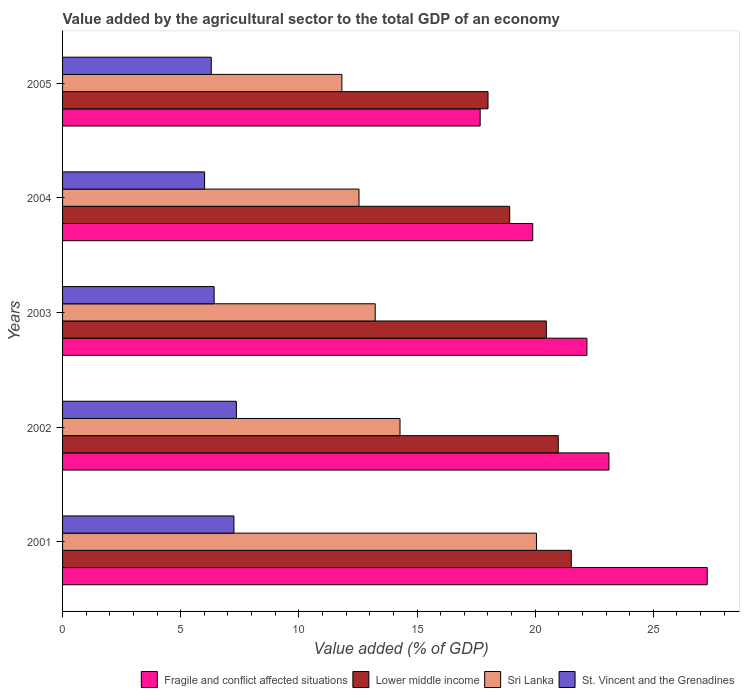How many different coloured bars are there?
Make the answer very short. 4. How many groups of bars are there?
Your answer should be compact. 5. How many bars are there on the 4th tick from the top?
Your answer should be very brief. 4. How many bars are there on the 4th tick from the bottom?
Make the answer very short. 4. What is the label of the 2nd group of bars from the top?
Provide a short and direct response. 2004. In how many cases, is the number of bars for a given year not equal to the number of legend labels?
Your answer should be compact. 0. What is the value added by the agricultural sector to the total GDP in Sri Lanka in 2004?
Give a very brief answer. 12.54. Across all years, what is the maximum value added by the agricultural sector to the total GDP in Lower middle income?
Your answer should be compact. 21.53. Across all years, what is the minimum value added by the agricultural sector to the total GDP in St. Vincent and the Grenadines?
Your response must be concise. 6.01. In which year was the value added by the agricultural sector to the total GDP in St. Vincent and the Grenadines maximum?
Ensure brevity in your answer.  2002. What is the total value added by the agricultural sector to the total GDP in Fragile and conflict affected situations in the graph?
Make the answer very short. 110.16. What is the difference between the value added by the agricultural sector to the total GDP in Lower middle income in 2001 and that in 2004?
Offer a terse response. 2.61. What is the difference between the value added by the agricultural sector to the total GDP in Fragile and conflict affected situations in 2001 and the value added by the agricultural sector to the total GDP in St. Vincent and the Grenadines in 2003?
Ensure brevity in your answer.  20.87. What is the average value added by the agricultural sector to the total GDP in Sri Lanka per year?
Offer a very short reply. 14.39. In the year 2005, what is the difference between the value added by the agricultural sector to the total GDP in Fragile and conflict affected situations and value added by the agricultural sector to the total GDP in Lower middle income?
Make the answer very short. -0.33. What is the ratio of the value added by the agricultural sector to the total GDP in Lower middle income in 2002 to that in 2004?
Provide a succinct answer. 1.11. What is the difference between the highest and the second highest value added by the agricultural sector to the total GDP in St. Vincent and the Grenadines?
Offer a terse response. 0.1. What is the difference between the highest and the lowest value added by the agricultural sector to the total GDP in Lower middle income?
Your response must be concise. 3.52. In how many years, is the value added by the agricultural sector to the total GDP in St. Vincent and the Grenadines greater than the average value added by the agricultural sector to the total GDP in St. Vincent and the Grenadines taken over all years?
Give a very brief answer. 2. Is the sum of the value added by the agricultural sector to the total GDP in Sri Lanka in 2002 and 2005 greater than the maximum value added by the agricultural sector to the total GDP in St. Vincent and the Grenadines across all years?
Provide a succinct answer. Yes. Is it the case that in every year, the sum of the value added by the agricultural sector to the total GDP in St. Vincent and the Grenadines and value added by the agricultural sector to the total GDP in Sri Lanka is greater than the sum of value added by the agricultural sector to the total GDP in Fragile and conflict affected situations and value added by the agricultural sector to the total GDP in Lower middle income?
Provide a short and direct response. No. What does the 4th bar from the top in 2005 represents?
Make the answer very short. Fragile and conflict affected situations. What does the 3rd bar from the bottom in 2005 represents?
Make the answer very short. Sri Lanka. Are all the bars in the graph horizontal?
Your answer should be very brief. Yes. How many years are there in the graph?
Keep it short and to the point. 5. What is the difference between two consecutive major ticks on the X-axis?
Keep it short and to the point. 5. Are the values on the major ticks of X-axis written in scientific E-notation?
Keep it short and to the point. No. Does the graph contain any zero values?
Your response must be concise. No. Where does the legend appear in the graph?
Offer a terse response. Bottom right. How many legend labels are there?
Offer a terse response. 4. What is the title of the graph?
Keep it short and to the point. Value added by the agricultural sector to the total GDP of an economy. Does "Swaziland" appear as one of the legend labels in the graph?
Your answer should be compact. No. What is the label or title of the X-axis?
Provide a short and direct response. Value added (% of GDP). What is the label or title of the Y-axis?
Your answer should be very brief. Years. What is the Value added (% of GDP) of Fragile and conflict affected situations in 2001?
Your response must be concise. 27.28. What is the Value added (% of GDP) in Lower middle income in 2001?
Ensure brevity in your answer.  21.53. What is the Value added (% of GDP) in Sri Lanka in 2001?
Your response must be concise. 20.05. What is the Value added (% of GDP) of St. Vincent and the Grenadines in 2001?
Make the answer very short. 7.25. What is the Value added (% of GDP) in Fragile and conflict affected situations in 2002?
Keep it short and to the point. 23.12. What is the Value added (% of GDP) in Lower middle income in 2002?
Provide a short and direct response. 20.98. What is the Value added (% of GDP) in Sri Lanka in 2002?
Keep it short and to the point. 14.28. What is the Value added (% of GDP) of St. Vincent and the Grenadines in 2002?
Keep it short and to the point. 7.36. What is the Value added (% of GDP) in Fragile and conflict affected situations in 2003?
Offer a terse response. 22.19. What is the Value added (% of GDP) of Lower middle income in 2003?
Ensure brevity in your answer.  20.47. What is the Value added (% of GDP) in Sri Lanka in 2003?
Keep it short and to the point. 13.23. What is the Value added (% of GDP) in St. Vincent and the Grenadines in 2003?
Provide a succinct answer. 6.41. What is the Value added (% of GDP) of Fragile and conflict affected situations in 2004?
Provide a succinct answer. 19.9. What is the Value added (% of GDP) in Lower middle income in 2004?
Provide a short and direct response. 18.92. What is the Value added (% of GDP) in Sri Lanka in 2004?
Your answer should be very brief. 12.54. What is the Value added (% of GDP) of St. Vincent and the Grenadines in 2004?
Offer a terse response. 6.01. What is the Value added (% of GDP) in Fragile and conflict affected situations in 2005?
Your answer should be very brief. 17.67. What is the Value added (% of GDP) of Lower middle income in 2005?
Your answer should be compact. 18. What is the Value added (% of GDP) in Sri Lanka in 2005?
Make the answer very short. 11.82. What is the Value added (% of GDP) in St. Vincent and the Grenadines in 2005?
Your answer should be compact. 6.29. Across all years, what is the maximum Value added (% of GDP) in Fragile and conflict affected situations?
Your answer should be compact. 27.28. Across all years, what is the maximum Value added (% of GDP) in Lower middle income?
Ensure brevity in your answer.  21.53. Across all years, what is the maximum Value added (% of GDP) of Sri Lanka?
Keep it short and to the point. 20.05. Across all years, what is the maximum Value added (% of GDP) of St. Vincent and the Grenadines?
Give a very brief answer. 7.36. Across all years, what is the minimum Value added (% of GDP) of Fragile and conflict affected situations?
Offer a terse response. 17.67. Across all years, what is the minimum Value added (% of GDP) of Lower middle income?
Your answer should be very brief. 18. Across all years, what is the minimum Value added (% of GDP) of Sri Lanka?
Your answer should be compact. 11.82. Across all years, what is the minimum Value added (% of GDP) in St. Vincent and the Grenadines?
Provide a succinct answer. 6.01. What is the total Value added (% of GDP) of Fragile and conflict affected situations in the graph?
Your answer should be very brief. 110.16. What is the total Value added (% of GDP) in Lower middle income in the graph?
Your response must be concise. 99.9. What is the total Value added (% of GDP) in Sri Lanka in the graph?
Ensure brevity in your answer.  71.93. What is the total Value added (% of GDP) of St. Vincent and the Grenadines in the graph?
Provide a short and direct response. 33.32. What is the difference between the Value added (% of GDP) in Fragile and conflict affected situations in 2001 and that in 2002?
Give a very brief answer. 4.16. What is the difference between the Value added (% of GDP) in Lower middle income in 2001 and that in 2002?
Your answer should be compact. 0.55. What is the difference between the Value added (% of GDP) of Sri Lanka in 2001 and that in 2002?
Provide a succinct answer. 5.77. What is the difference between the Value added (% of GDP) in St. Vincent and the Grenadines in 2001 and that in 2002?
Your answer should be very brief. -0.1. What is the difference between the Value added (% of GDP) in Fragile and conflict affected situations in 2001 and that in 2003?
Your answer should be compact. 5.09. What is the difference between the Value added (% of GDP) of Lower middle income in 2001 and that in 2003?
Make the answer very short. 1.05. What is the difference between the Value added (% of GDP) of Sri Lanka in 2001 and that in 2003?
Make the answer very short. 6.82. What is the difference between the Value added (% of GDP) in St. Vincent and the Grenadines in 2001 and that in 2003?
Give a very brief answer. 0.84. What is the difference between the Value added (% of GDP) of Fragile and conflict affected situations in 2001 and that in 2004?
Your response must be concise. 7.38. What is the difference between the Value added (% of GDP) of Lower middle income in 2001 and that in 2004?
Provide a succinct answer. 2.61. What is the difference between the Value added (% of GDP) in Sri Lanka in 2001 and that in 2004?
Provide a succinct answer. 7.51. What is the difference between the Value added (% of GDP) in St. Vincent and the Grenadines in 2001 and that in 2004?
Offer a terse response. 1.24. What is the difference between the Value added (% of GDP) of Fragile and conflict affected situations in 2001 and that in 2005?
Provide a succinct answer. 9.61. What is the difference between the Value added (% of GDP) of Lower middle income in 2001 and that in 2005?
Give a very brief answer. 3.52. What is the difference between the Value added (% of GDP) in Sri Lanka in 2001 and that in 2005?
Provide a succinct answer. 8.23. What is the difference between the Value added (% of GDP) of St. Vincent and the Grenadines in 2001 and that in 2005?
Offer a very short reply. 0.96. What is the difference between the Value added (% of GDP) in Fragile and conflict affected situations in 2002 and that in 2003?
Offer a terse response. 0.93. What is the difference between the Value added (% of GDP) in Lower middle income in 2002 and that in 2003?
Ensure brevity in your answer.  0.5. What is the difference between the Value added (% of GDP) of Sri Lanka in 2002 and that in 2003?
Keep it short and to the point. 1.05. What is the difference between the Value added (% of GDP) in St. Vincent and the Grenadines in 2002 and that in 2003?
Your response must be concise. 0.94. What is the difference between the Value added (% of GDP) of Fragile and conflict affected situations in 2002 and that in 2004?
Offer a terse response. 3.23. What is the difference between the Value added (% of GDP) in Lower middle income in 2002 and that in 2004?
Your answer should be compact. 2.05. What is the difference between the Value added (% of GDP) in Sri Lanka in 2002 and that in 2004?
Make the answer very short. 1.74. What is the difference between the Value added (% of GDP) in St. Vincent and the Grenadines in 2002 and that in 2004?
Provide a short and direct response. 1.35. What is the difference between the Value added (% of GDP) of Fragile and conflict affected situations in 2002 and that in 2005?
Provide a succinct answer. 5.45. What is the difference between the Value added (% of GDP) in Lower middle income in 2002 and that in 2005?
Offer a terse response. 2.97. What is the difference between the Value added (% of GDP) in Sri Lanka in 2002 and that in 2005?
Offer a terse response. 2.46. What is the difference between the Value added (% of GDP) in St. Vincent and the Grenadines in 2002 and that in 2005?
Offer a terse response. 1.06. What is the difference between the Value added (% of GDP) of Fragile and conflict affected situations in 2003 and that in 2004?
Give a very brief answer. 2.29. What is the difference between the Value added (% of GDP) of Lower middle income in 2003 and that in 2004?
Your answer should be compact. 1.55. What is the difference between the Value added (% of GDP) in Sri Lanka in 2003 and that in 2004?
Your response must be concise. 0.69. What is the difference between the Value added (% of GDP) of St. Vincent and the Grenadines in 2003 and that in 2004?
Make the answer very short. 0.4. What is the difference between the Value added (% of GDP) of Fragile and conflict affected situations in 2003 and that in 2005?
Offer a terse response. 4.52. What is the difference between the Value added (% of GDP) of Lower middle income in 2003 and that in 2005?
Your answer should be compact. 2.47. What is the difference between the Value added (% of GDP) in Sri Lanka in 2003 and that in 2005?
Keep it short and to the point. 1.41. What is the difference between the Value added (% of GDP) in St. Vincent and the Grenadines in 2003 and that in 2005?
Make the answer very short. 0.12. What is the difference between the Value added (% of GDP) of Fragile and conflict affected situations in 2004 and that in 2005?
Keep it short and to the point. 2.22. What is the difference between the Value added (% of GDP) of Lower middle income in 2004 and that in 2005?
Give a very brief answer. 0.92. What is the difference between the Value added (% of GDP) of Sri Lanka in 2004 and that in 2005?
Your response must be concise. 0.72. What is the difference between the Value added (% of GDP) of St. Vincent and the Grenadines in 2004 and that in 2005?
Offer a very short reply. -0.28. What is the difference between the Value added (% of GDP) of Fragile and conflict affected situations in 2001 and the Value added (% of GDP) of Lower middle income in 2002?
Keep it short and to the point. 6.31. What is the difference between the Value added (% of GDP) in Fragile and conflict affected situations in 2001 and the Value added (% of GDP) in Sri Lanka in 2002?
Your response must be concise. 13. What is the difference between the Value added (% of GDP) of Fragile and conflict affected situations in 2001 and the Value added (% of GDP) of St. Vincent and the Grenadines in 2002?
Make the answer very short. 19.92. What is the difference between the Value added (% of GDP) in Lower middle income in 2001 and the Value added (% of GDP) in Sri Lanka in 2002?
Provide a succinct answer. 7.25. What is the difference between the Value added (% of GDP) of Lower middle income in 2001 and the Value added (% of GDP) of St. Vincent and the Grenadines in 2002?
Offer a terse response. 14.17. What is the difference between the Value added (% of GDP) of Sri Lanka in 2001 and the Value added (% of GDP) of St. Vincent and the Grenadines in 2002?
Give a very brief answer. 12.7. What is the difference between the Value added (% of GDP) of Fragile and conflict affected situations in 2001 and the Value added (% of GDP) of Lower middle income in 2003?
Ensure brevity in your answer.  6.81. What is the difference between the Value added (% of GDP) in Fragile and conflict affected situations in 2001 and the Value added (% of GDP) in Sri Lanka in 2003?
Keep it short and to the point. 14.05. What is the difference between the Value added (% of GDP) of Fragile and conflict affected situations in 2001 and the Value added (% of GDP) of St. Vincent and the Grenadines in 2003?
Your answer should be compact. 20.87. What is the difference between the Value added (% of GDP) of Lower middle income in 2001 and the Value added (% of GDP) of Sri Lanka in 2003?
Keep it short and to the point. 8.3. What is the difference between the Value added (% of GDP) of Lower middle income in 2001 and the Value added (% of GDP) of St. Vincent and the Grenadines in 2003?
Offer a very short reply. 15.11. What is the difference between the Value added (% of GDP) of Sri Lanka in 2001 and the Value added (% of GDP) of St. Vincent and the Grenadines in 2003?
Give a very brief answer. 13.64. What is the difference between the Value added (% of GDP) in Fragile and conflict affected situations in 2001 and the Value added (% of GDP) in Lower middle income in 2004?
Your answer should be very brief. 8.36. What is the difference between the Value added (% of GDP) in Fragile and conflict affected situations in 2001 and the Value added (% of GDP) in Sri Lanka in 2004?
Your answer should be compact. 14.74. What is the difference between the Value added (% of GDP) in Fragile and conflict affected situations in 2001 and the Value added (% of GDP) in St. Vincent and the Grenadines in 2004?
Offer a very short reply. 21.27. What is the difference between the Value added (% of GDP) in Lower middle income in 2001 and the Value added (% of GDP) in Sri Lanka in 2004?
Keep it short and to the point. 8.98. What is the difference between the Value added (% of GDP) of Lower middle income in 2001 and the Value added (% of GDP) of St. Vincent and the Grenadines in 2004?
Give a very brief answer. 15.52. What is the difference between the Value added (% of GDP) in Sri Lanka in 2001 and the Value added (% of GDP) in St. Vincent and the Grenadines in 2004?
Provide a short and direct response. 14.04. What is the difference between the Value added (% of GDP) of Fragile and conflict affected situations in 2001 and the Value added (% of GDP) of Lower middle income in 2005?
Make the answer very short. 9.28. What is the difference between the Value added (% of GDP) of Fragile and conflict affected situations in 2001 and the Value added (% of GDP) of Sri Lanka in 2005?
Your answer should be compact. 15.46. What is the difference between the Value added (% of GDP) in Fragile and conflict affected situations in 2001 and the Value added (% of GDP) in St. Vincent and the Grenadines in 2005?
Your answer should be very brief. 20.99. What is the difference between the Value added (% of GDP) of Lower middle income in 2001 and the Value added (% of GDP) of Sri Lanka in 2005?
Give a very brief answer. 9.71. What is the difference between the Value added (% of GDP) in Lower middle income in 2001 and the Value added (% of GDP) in St. Vincent and the Grenadines in 2005?
Provide a short and direct response. 15.24. What is the difference between the Value added (% of GDP) of Sri Lanka in 2001 and the Value added (% of GDP) of St. Vincent and the Grenadines in 2005?
Your answer should be compact. 13.76. What is the difference between the Value added (% of GDP) in Fragile and conflict affected situations in 2002 and the Value added (% of GDP) in Lower middle income in 2003?
Give a very brief answer. 2.65. What is the difference between the Value added (% of GDP) in Fragile and conflict affected situations in 2002 and the Value added (% of GDP) in Sri Lanka in 2003?
Ensure brevity in your answer.  9.89. What is the difference between the Value added (% of GDP) in Fragile and conflict affected situations in 2002 and the Value added (% of GDP) in St. Vincent and the Grenadines in 2003?
Ensure brevity in your answer.  16.71. What is the difference between the Value added (% of GDP) of Lower middle income in 2002 and the Value added (% of GDP) of Sri Lanka in 2003?
Your response must be concise. 7.74. What is the difference between the Value added (% of GDP) of Lower middle income in 2002 and the Value added (% of GDP) of St. Vincent and the Grenadines in 2003?
Make the answer very short. 14.56. What is the difference between the Value added (% of GDP) of Sri Lanka in 2002 and the Value added (% of GDP) of St. Vincent and the Grenadines in 2003?
Give a very brief answer. 7.87. What is the difference between the Value added (% of GDP) in Fragile and conflict affected situations in 2002 and the Value added (% of GDP) in Lower middle income in 2004?
Your response must be concise. 4.2. What is the difference between the Value added (% of GDP) of Fragile and conflict affected situations in 2002 and the Value added (% of GDP) of Sri Lanka in 2004?
Ensure brevity in your answer.  10.58. What is the difference between the Value added (% of GDP) in Fragile and conflict affected situations in 2002 and the Value added (% of GDP) in St. Vincent and the Grenadines in 2004?
Your answer should be very brief. 17.11. What is the difference between the Value added (% of GDP) of Lower middle income in 2002 and the Value added (% of GDP) of Sri Lanka in 2004?
Ensure brevity in your answer.  8.43. What is the difference between the Value added (% of GDP) in Lower middle income in 2002 and the Value added (% of GDP) in St. Vincent and the Grenadines in 2004?
Provide a short and direct response. 14.97. What is the difference between the Value added (% of GDP) in Sri Lanka in 2002 and the Value added (% of GDP) in St. Vincent and the Grenadines in 2004?
Ensure brevity in your answer.  8.27. What is the difference between the Value added (% of GDP) in Fragile and conflict affected situations in 2002 and the Value added (% of GDP) in Lower middle income in 2005?
Keep it short and to the point. 5.12. What is the difference between the Value added (% of GDP) in Fragile and conflict affected situations in 2002 and the Value added (% of GDP) in Sri Lanka in 2005?
Provide a short and direct response. 11.3. What is the difference between the Value added (% of GDP) in Fragile and conflict affected situations in 2002 and the Value added (% of GDP) in St. Vincent and the Grenadines in 2005?
Your answer should be very brief. 16.83. What is the difference between the Value added (% of GDP) in Lower middle income in 2002 and the Value added (% of GDP) in Sri Lanka in 2005?
Your answer should be very brief. 9.16. What is the difference between the Value added (% of GDP) in Lower middle income in 2002 and the Value added (% of GDP) in St. Vincent and the Grenadines in 2005?
Give a very brief answer. 14.68. What is the difference between the Value added (% of GDP) of Sri Lanka in 2002 and the Value added (% of GDP) of St. Vincent and the Grenadines in 2005?
Your answer should be very brief. 7.99. What is the difference between the Value added (% of GDP) of Fragile and conflict affected situations in 2003 and the Value added (% of GDP) of Lower middle income in 2004?
Ensure brevity in your answer.  3.27. What is the difference between the Value added (% of GDP) in Fragile and conflict affected situations in 2003 and the Value added (% of GDP) in Sri Lanka in 2004?
Provide a succinct answer. 9.64. What is the difference between the Value added (% of GDP) of Fragile and conflict affected situations in 2003 and the Value added (% of GDP) of St. Vincent and the Grenadines in 2004?
Give a very brief answer. 16.18. What is the difference between the Value added (% of GDP) of Lower middle income in 2003 and the Value added (% of GDP) of Sri Lanka in 2004?
Ensure brevity in your answer.  7.93. What is the difference between the Value added (% of GDP) of Lower middle income in 2003 and the Value added (% of GDP) of St. Vincent and the Grenadines in 2004?
Provide a succinct answer. 14.46. What is the difference between the Value added (% of GDP) of Sri Lanka in 2003 and the Value added (% of GDP) of St. Vincent and the Grenadines in 2004?
Ensure brevity in your answer.  7.22. What is the difference between the Value added (% of GDP) of Fragile and conflict affected situations in 2003 and the Value added (% of GDP) of Lower middle income in 2005?
Your answer should be compact. 4.18. What is the difference between the Value added (% of GDP) in Fragile and conflict affected situations in 2003 and the Value added (% of GDP) in Sri Lanka in 2005?
Provide a short and direct response. 10.37. What is the difference between the Value added (% of GDP) in Fragile and conflict affected situations in 2003 and the Value added (% of GDP) in St. Vincent and the Grenadines in 2005?
Offer a terse response. 15.9. What is the difference between the Value added (% of GDP) of Lower middle income in 2003 and the Value added (% of GDP) of Sri Lanka in 2005?
Your response must be concise. 8.65. What is the difference between the Value added (% of GDP) in Lower middle income in 2003 and the Value added (% of GDP) in St. Vincent and the Grenadines in 2005?
Make the answer very short. 14.18. What is the difference between the Value added (% of GDP) of Sri Lanka in 2003 and the Value added (% of GDP) of St. Vincent and the Grenadines in 2005?
Offer a terse response. 6.94. What is the difference between the Value added (% of GDP) in Fragile and conflict affected situations in 2004 and the Value added (% of GDP) in Lower middle income in 2005?
Provide a succinct answer. 1.89. What is the difference between the Value added (% of GDP) of Fragile and conflict affected situations in 2004 and the Value added (% of GDP) of Sri Lanka in 2005?
Your answer should be compact. 8.08. What is the difference between the Value added (% of GDP) in Fragile and conflict affected situations in 2004 and the Value added (% of GDP) in St. Vincent and the Grenadines in 2005?
Provide a short and direct response. 13.6. What is the difference between the Value added (% of GDP) in Lower middle income in 2004 and the Value added (% of GDP) in Sri Lanka in 2005?
Provide a succinct answer. 7.1. What is the difference between the Value added (% of GDP) in Lower middle income in 2004 and the Value added (% of GDP) in St. Vincent and the Grenadines in 2005?
Your answer should be very brief. 12.63. What is the difference between the Value added (% of GDP) in Sri Lanka in 2004 and the Value added (% of GDP) in St. Vincent and the Grenadines in 2005?
Ensure brevity in your answer.  6.25. What is the average Value added (% of GDP) of Fragile and conflict affected situations per year?
Your answer should be very brief. 22.03. What is the average Value added (% of GDP) of Lower middle income per year?
Ensure brevity in your answer.  19.98. What is the average Value added (% of GDP) in Sri Lanka per year?
Provide a short and direct response. 14.39. What is the average Value added (% of GDP) in St. Vincent and the Grenadines per year?
Provide a succinct answer. 6.66. In the year 2001, what is the difference between the Value added (% of GDP) in Fragile and conflict affected situations and Value added (% of GDP) in Lower middle income?
Offer a very short reply. 5.75. In the year 2001, what is the difference between the Value added (% of GDP) in Fragile and conflict affected situations and Value added (% of GDP) in Sri Lanka?
Offer a terse response. 7.23. In the year 2001, what is the difference between the Value added (% of GDP) in Fragile and conflict affected situations and Value added (% of GDP) in St. Vincent and the Grenadines?
Offer a very short reply. 20.03. In the year 2001, what is the difference between the Value added (% of GDP) of Lower middle income and Value added (% of GDP) of Sri Lanka?
Give a very brief answer. 1.47. In the year 2001, what is the difference between the Value added (% of GDP) of Lower middle income and Value added (% of GDP) of St. Vincent and the Grenadines?
Give a very brief answer. 14.28. In the year 2001, what is the difference between the Value added (% of GDP) of Sri Lanka and Value added (% of GDP) of St. Vincent and the Grenadines?
Keep it short and to the point. 12.8. In the year 2002, what is the difference between the Value added (% of GDP) of Fragile and conflict affected situations and Value added (% of GDP) of Lower middle income?
Provide a short and direct response. 2.15. In the year 2002, what is the difference between the Value added (% of GDP) of Fragile and conflict affected situations and Value added (% of GDP) of Sri Lanka?
Provide a short and direct response. 8.84. In the year 2002, what is the difference between the Value added (% of GDP) in Fragile and conflict affected situations and Value added (% of GDP) in St. Vincent and the Grenadines?
Keep it short and to the point. 15.76. In the year 2002, what is the difference between the Value added (% of GDP) of Lower middle income and Value added (% of GDP) of Sri Lanka?
Provide a succinct answer. 6.7. In the year 2002, what is the difference between the Value added (% of GDP) of Lower middle income and Value added (% of GDP) of St. Vincent and the Grenadines?
Your answer should be very brief. 13.62. In the year 2002, what is the difference between the Value added (% of GDP) in Sri Lanka and Value added (% of GDP) in St. Vincent and the Grenadines?
Your answer should be very brief. 6.92. In the year 2003, what is the difference between the Value added (% of GDP) of Fragile and conflict affected situations and Value added (% of GDP) of Lower middle income?
Make the answer very short. 1.71. In the year 2003, what is the difference between the Value added (% of GDP) in Fragile and conflict affected situations and Value added (% of GDP) in Sri Lanka?
Make the answer very short. 8.96. In the year 2003, what is the difference between the Value added (% of GDP) in Fragile and conflict affected situations and Value added (% of GDP) in St. Vincent and the Grenadines?
Ensure brevity in your answer.  15.77. In the year 2003, what is the difference between the Value added (% of GDP) in Lower middle income and Value added (% of GDP) in Sri Lanka?
Your answer should be compact. 7.24. In the year 2003, what is the difference between the Value added (% of GDP) in Lower middle income and Value added (% of GDP) in St. Vincent and the Grenadines?
Offer a terse response. 14.06. In the year 2003, what is the difference between the Value added (% of GDP) of Sri Lanka and Value added (% of GDP) of St. Vincent and the Grenadines?
Make the answer very short. 6.82. In the year 2004, what is the difference between the Value added (% of GDP) of Fragile and conflict affected situations and Value added (% of GDP) of Lower middle income?
Provide a succinct answer. 0.97. In the year 2004, what is the difference between the Value added (% of GDP) in Fragile and conflict affected situations and Value added (% of GDP) in Sri Lanka?
Keep it short and to the point. 7.35. In the year 2004, what is the difference between the Value added (% of GDP) in Fragile and conflict affected situations and Value added (% of GDP) in St. Vincent and the Grenadines?
Ensure brevity in your answer.  13.89. In the year 2004, what is the difference between the Value added (% of GDP) of Lower middle income and Value added (% of GDP) of Sri Lanka?
Provide a succinct answer. 6.38. In the year 2004, what is the difference between the Value added (% of GDP) in Lower middle income and Value added (% of GDP) in St. Vincent and the Grenadines?
Offer a terse response. 12.91. In the year 2004, what is the difference between the Value added (% of GDP) of Sri Lanka and Value added (% of GDP) of St. Vincent and the Grenadines?
Provide a short and direct response. 6.53. In the year 2005, what is the difference between the Value added (% of GDP) in Fragile and conflict affected situations and Value added (% of GDP) in Lower middle income?
Offer a very short reply. -0.33. In the year 2005, what is the difference between the Value added (% of GDP) of Fragile and conflict affected situations and Value added (% of GDP) of Sri Lanka?
Keep it short and to the point. 5.85. In the year 2005, what is the difference between the Value added (% of GDP) in Fragile and conflict affected situations and Value added (% of GDP) in St. Vincent and the Grenadines?
Provide a short and direct response. 11.38. In the year 2005, what is the difference between the Value added (% of GDP) of Lower middle income and Value added (% of GDP) of Sri Lanka?
Your response must be concise. 6.18. In the year 2005, what is the difference between the Value added (% of GDP) in Lower middle income and Value added (% of GDP) in St. Vincent and the Grenadines?
Keep it short and to the point. 11.71. In the year 2005, what is the difference between the Value added (% of GDP) of Sri Lanka and Value added (% of GDP) of St. Vincent and the Grenadines?
Ensure brevity in your answer.  5.53. What is the ratio of the Value added (% of GDP) in Fragile and conflict affected situations in 2001 to that in 2002?
Provide a succinct answer. 1.18. What is the ratio of the Value added (% of GDP) of Lower middle income in 2001 to that in 2002?
Keep it short and to the point. 1.03. What is the ratio of the Value added (% of GDP) in Sri Lanka in 2001 to that in 2002?
Your response must be concise. 1.4. What is the ratio of the Value added (% of GDP) in St. Vincent and the Grenadines in 2001 to that in 2002?
Offer a very short reply. 0.99. What is the ratio of the Value added (% of GDP) in Fragile and conflict affected situations in 2001 to that in 2003?
Provide a short and direct response. 1.23. What is the ratio of the Value added (% of GDP) in Lower middle income in 2001 to that in 2003?
Offer a very short reply. 1.05. What is the ratio of the Value added (% of GDP) in Sri Lanka in 2001 to that in 2003?
Your answer should be very brief. 1.52. What is the ratio of the Value added (% of GDP) of St. Vincent and the Grenadines in 2001 to that in 2003?
Offer a terse response. 1.13. What is the ratio of the Value added (% of GDP) in Fragile and conflict affected situations in 2001 to that in 2004?
Offer a terse response. 1.37. What is the ratio of the Value added (% of GDP) in Lower middle income in 2001 to that in 2004?
Give a very brief answer. 1.14. What is the ratio of the Value added (% of GDP) of Sri Lanka in 2001 to that in 2004?
Ensure brevity in your answer.  1.6. What is the ratio of the Value added (% of GDP) in St. Vincent and the Grenadines in 2001 to that in 2004?
Provide a short and direct response. 1.21. What is the ratio of the Value added (% of GDP) of Fragile and conflict affected situations in 2001 to that in 2005?
Offer a terse response. 1.54. What is the ratio of the Value added (% of GDP) in Lower middle income in 2001 to that in 2005?
Provide a short and direct response. 1.2. What is the ratio of the Value added (% of GDP) of Sri Lanka in 2001 to that in 2005?
Ensure brevity in your answer.  1.7. What is the ratio of the Value added (% of GDP) in St. Vincent and the Grenadines in 2001 to that in 2005?
Offer a very short reply. 1.15. What is the ratio of the Value added (% of GDP) in Fragile and conflict affected situations in 2002 to that in 2003?
Provide a succinct answer. 1.04. What is the ratio of the Value added (% of GDP) in Lower middle income in 2002 to that in 2003?
Make the answer very short. 1.02. What is the ratio of the Value added (% of GDP) of Sri Lanka in 2002 to that in 2003?
Offer a very short reply. 1.08. What is the ratio of the Value added (% of GDP) of St. Vincent and the Grenadines in 2002 to that in 2003?
Give a very brief answer. 1.15. What is the ratio of the Value added (% of GDP) in Fragile and conflict affected situations in 2002 to that in 2004?
Make the answer very short. 1.16. What is the ratio of the Value added (% of GDP) of Lower middle income in 2002 to that in 2004?
Make the answer very short. 1.11. What is the ratio of the Value added (% of GDP) of Sri Lanka in 2002 to that in 2004?
Your answer should be compact. 1.14. What is the ratio of the Value added (% of GDP) in St. Vincent and the Grenadines in 2002 to that in 2004?
Offer a very short reply. 1.22. What is the ratio of the Value added (% of GDP) of Fragile and conflict affected situations in 2002 to that in 2005?
Keep it short and to the point. 1.31. What is the ratio of the Value added (% of GDP) of Lower middle income in 2002 to that in 2005?
Provide a succinct answer. 1.17. What is the ratio of the Value added (% of GDP) of Sri Lanka in 2002 to that in 2005?
Offer a very short reply. 1.21. What is the ratio of the Value added (% of GDP) in St. Vincent and the Grenadines in 2002 to that in 2005?
Your answer should be compact. 1.17. What is the ratio of the Value added (% of GDP) in Fragile and conflict affected situations in 2003 to that in 2004?
Your answer should be very brief. 1.12. What is the ratio of the Value added (% of GDP) in Lower middle income in 2003 to that in 2004?
Offer a very short reply. 1.08. What is the ratio of the Value added (% of GDP) in Sri Lanka in 2003 to that in 2004?
Provide a succinct answer. 1.05. What is the ratio of the Value added (% of GDP) of St. Vincent and the Grenadines in 2003 to that in 2004?
Provide a short and direct response. 1.07. What is the ratio of the Value added (% of GDP) in Fragile and conflict affected situations in 2003 to that in 2005?
Make the answer very short. 1.26. What is the ratio of the Value added (% of GDP) of Lower middle income in 2003 to that in 2005?
Your response must be concise. 1.14. What is the ratio of the Value added (% of GDP) of Sri Lanka in 2003 to that in 2005?
Your response must be concise. 1.12. What is the ratio of the Value added (% of GDP) of St. Vincent and the Grenadines in 2003 to that in 2005?
Your answer should be compact. 1.02. What is the ratio of the Value added (% of GDP) of Fragile and conflict affected situations in 2004 to that in 2005?
Offer a terse response. 1.13. What is the ratio of the Value added (% of GDP) in Lower middle income in 2004 to that in 2005?
Give a very brief answer. 1.05. What is the ratio of the Value added (% of GDP) of Sri Lanka in 2004 to that in 2005?
Your response must be concise. 1.06. What is the ratio of the Value added (% of GDP) in St. Vincent and the Grenadines in 2004 to that in 2005?
Keep it short and to the point. 0.96. What is the difference between the highest and the second highest Value added (% of GDP) of Fragile and conflict affected situations?
Make the answer very short. 4.16. What is the difference between the highest and the second highest Value added (% of GDP) in Lower middle income?
Offer a very short reply. 0.55. What is the difference between the highest and the second highest Value added (% of GDP) of Sri Lanka?
Your response must be concise. 5.77. What is the difference between the highest and the second highest Value added (% of GDP) in St. Vincent and the Grenadines?
Your response must be concise. 0.1. What is the difference between the highest and the lowest Value added (% of GDP) in Fragile and conflict affected situations?
Provide a succinct answer. 9.61. What is the difference between the highest and the lowest Value added (% of GDP) in Lower middle income?
Provide a succinct answer. 3.52. What is the difference between the highest and the lowest Value added (% of GDP) in Sri Lanka?
Give a very brief answer. 8.23. What is the difference between the highest and the lowest Value added (% of GDP) of St. Vincent and the Grenadines?
Give a very brief answer. 1.35. 